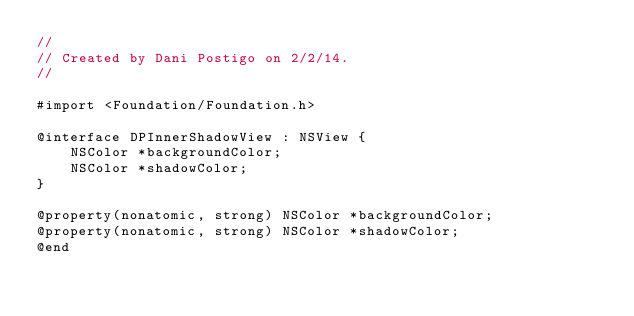<code> <loc_0><loc_0><loc_500><loc_500><_C_>//
// Created by Dani Postigo on 2/2/14.
//

#import <Foundation/Foundation.h>

@interface DPInnerShadowView : NSView {
    NSColor *backgroundColor;
    NSColor *shadowColor;
}

@property(nonatomic, strong) NSColor *backgroundColor;
@property(nonatomic, strong) NSColor *shadowColor;
@end</code> 